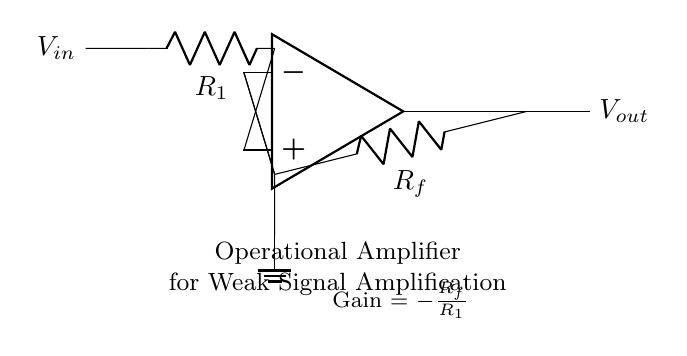What is the input voltage in this circuit? The input voltage is represented by \(V_{in}\) in the circuit diagram, which is indicated on the left side.
Answer: \(V_{in}\) What is the role of \(R_1\) in this circuit? \(R_1\) serves as the input resistor; it is connected from the input voltage to the non-inverting terminal of the operational amplifier and helps in determining the gain of the circuit.
Answer: Input resistor What is the feedback resistor in the circuit? The feedback resistor is labeled \(R_f\) in the diagram, which is connected from the output of the operational amplifier back to the inverting terminal.
Answer: \(R_f\) What is the gain formula for this operational amplifier? The gain is calculated as the ratio of the feedback resistance to the input resistance, which is labeled in the diagram as \(Gain = -\frac{R_f}{R_1}\).
Answer: Gain = -\(R_f\)/\(R_1\) Why is the output voltage labeled \(V_{out}\)? The output voltage is labeled \(V_{out}\) because it is the voltage produced at the output terminal of the operational amplifier, as indicated on the right side of the diagram.
Answer: \(V_{out}\) How does the configuration of this op-amp affect signal amplification? The operational amplifier configuration in this circuit is a non-inverting amplifier, which allows for amplification of weak signals applied to the input, thus producing a larger output voltage relative to the input signal.
Answer: Non-inverting amplifier What is the ground connection used for in this circuit? The ground connection is used as a reference point for the circuit and ensures that all voltage levels are measured relative to this common ground, providing a return path for current.
Answer: Reference point 